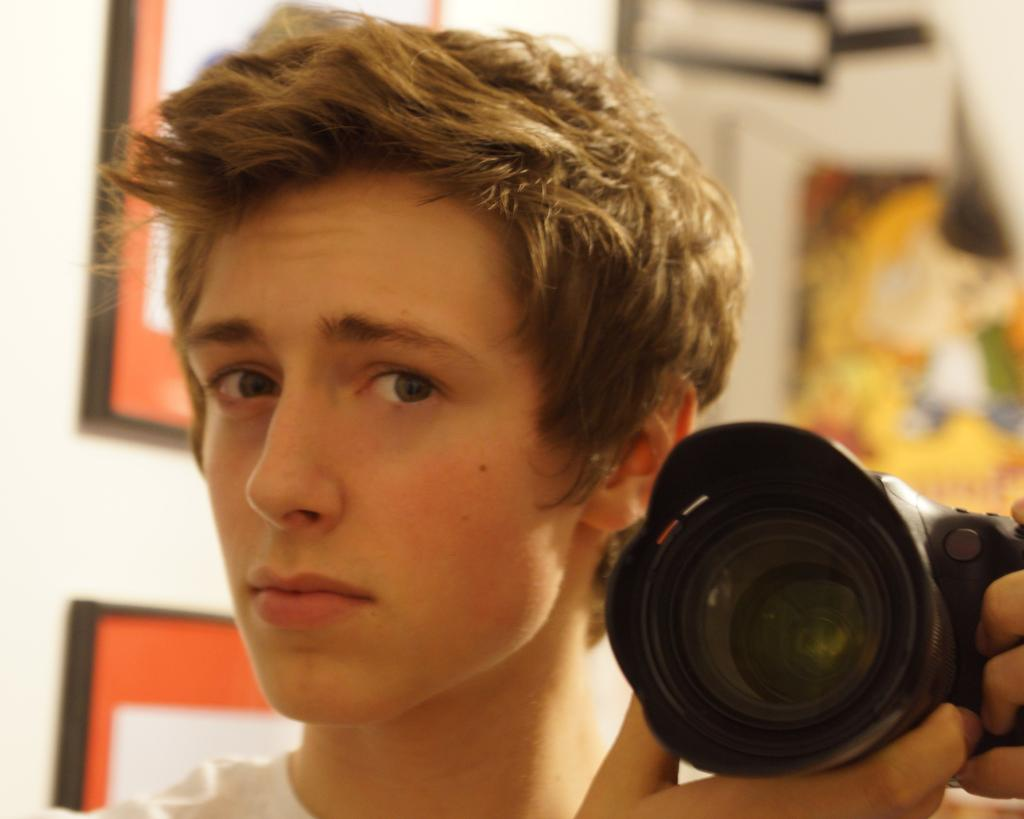Who is present in the image? There is a man in the image. What is the man doing in the image? The man is standing in the image. What is the man holding in his hands? The man is holding a camera in his hands. How many pigs are visible in the image? There are no pigs present in the image. What type of payment is being exchanged in the image? There is no payment being exchanged in the image. 